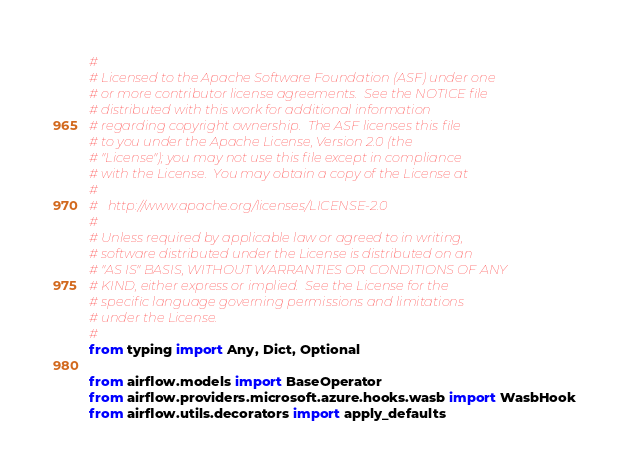Convert code to text. <code><loc_0><loc_0><loc_500><loc_500><_Python_>#
# Licensed to the Apache Software Foundation (ASF) under one
# or more contributor license agreements.  See the NOTICE file
# distributed with this work for additional information
# regarding copyright ownership.  The ASF licenses this file
# to you under the Apache License, Version 2.0 (the
# "License"); you may not use this file except in compliance
# with the License.  You may obtain a copy of the License at
#
#   http://www.apache.org/licenses/LICENSE-2.0
#
# Unless required by applicable law or agreed to in writing,
# software distributed under the License is distributed on an
# "AS IS" BASIS, WITHOUT WARRANTIES OR CONDITIONS OF ANY
# KIND, either express or implied.  See the License for the
# specific language governing permissions and limitations
# under the License.
#
from typing import Any, Dict, Optional

from airflow.models import BaseOperator
from airflow.providers.microsoft.azure.hooks.wasb import WasbHook
from airflow.utils.decorators import apply_defaults

</code> 